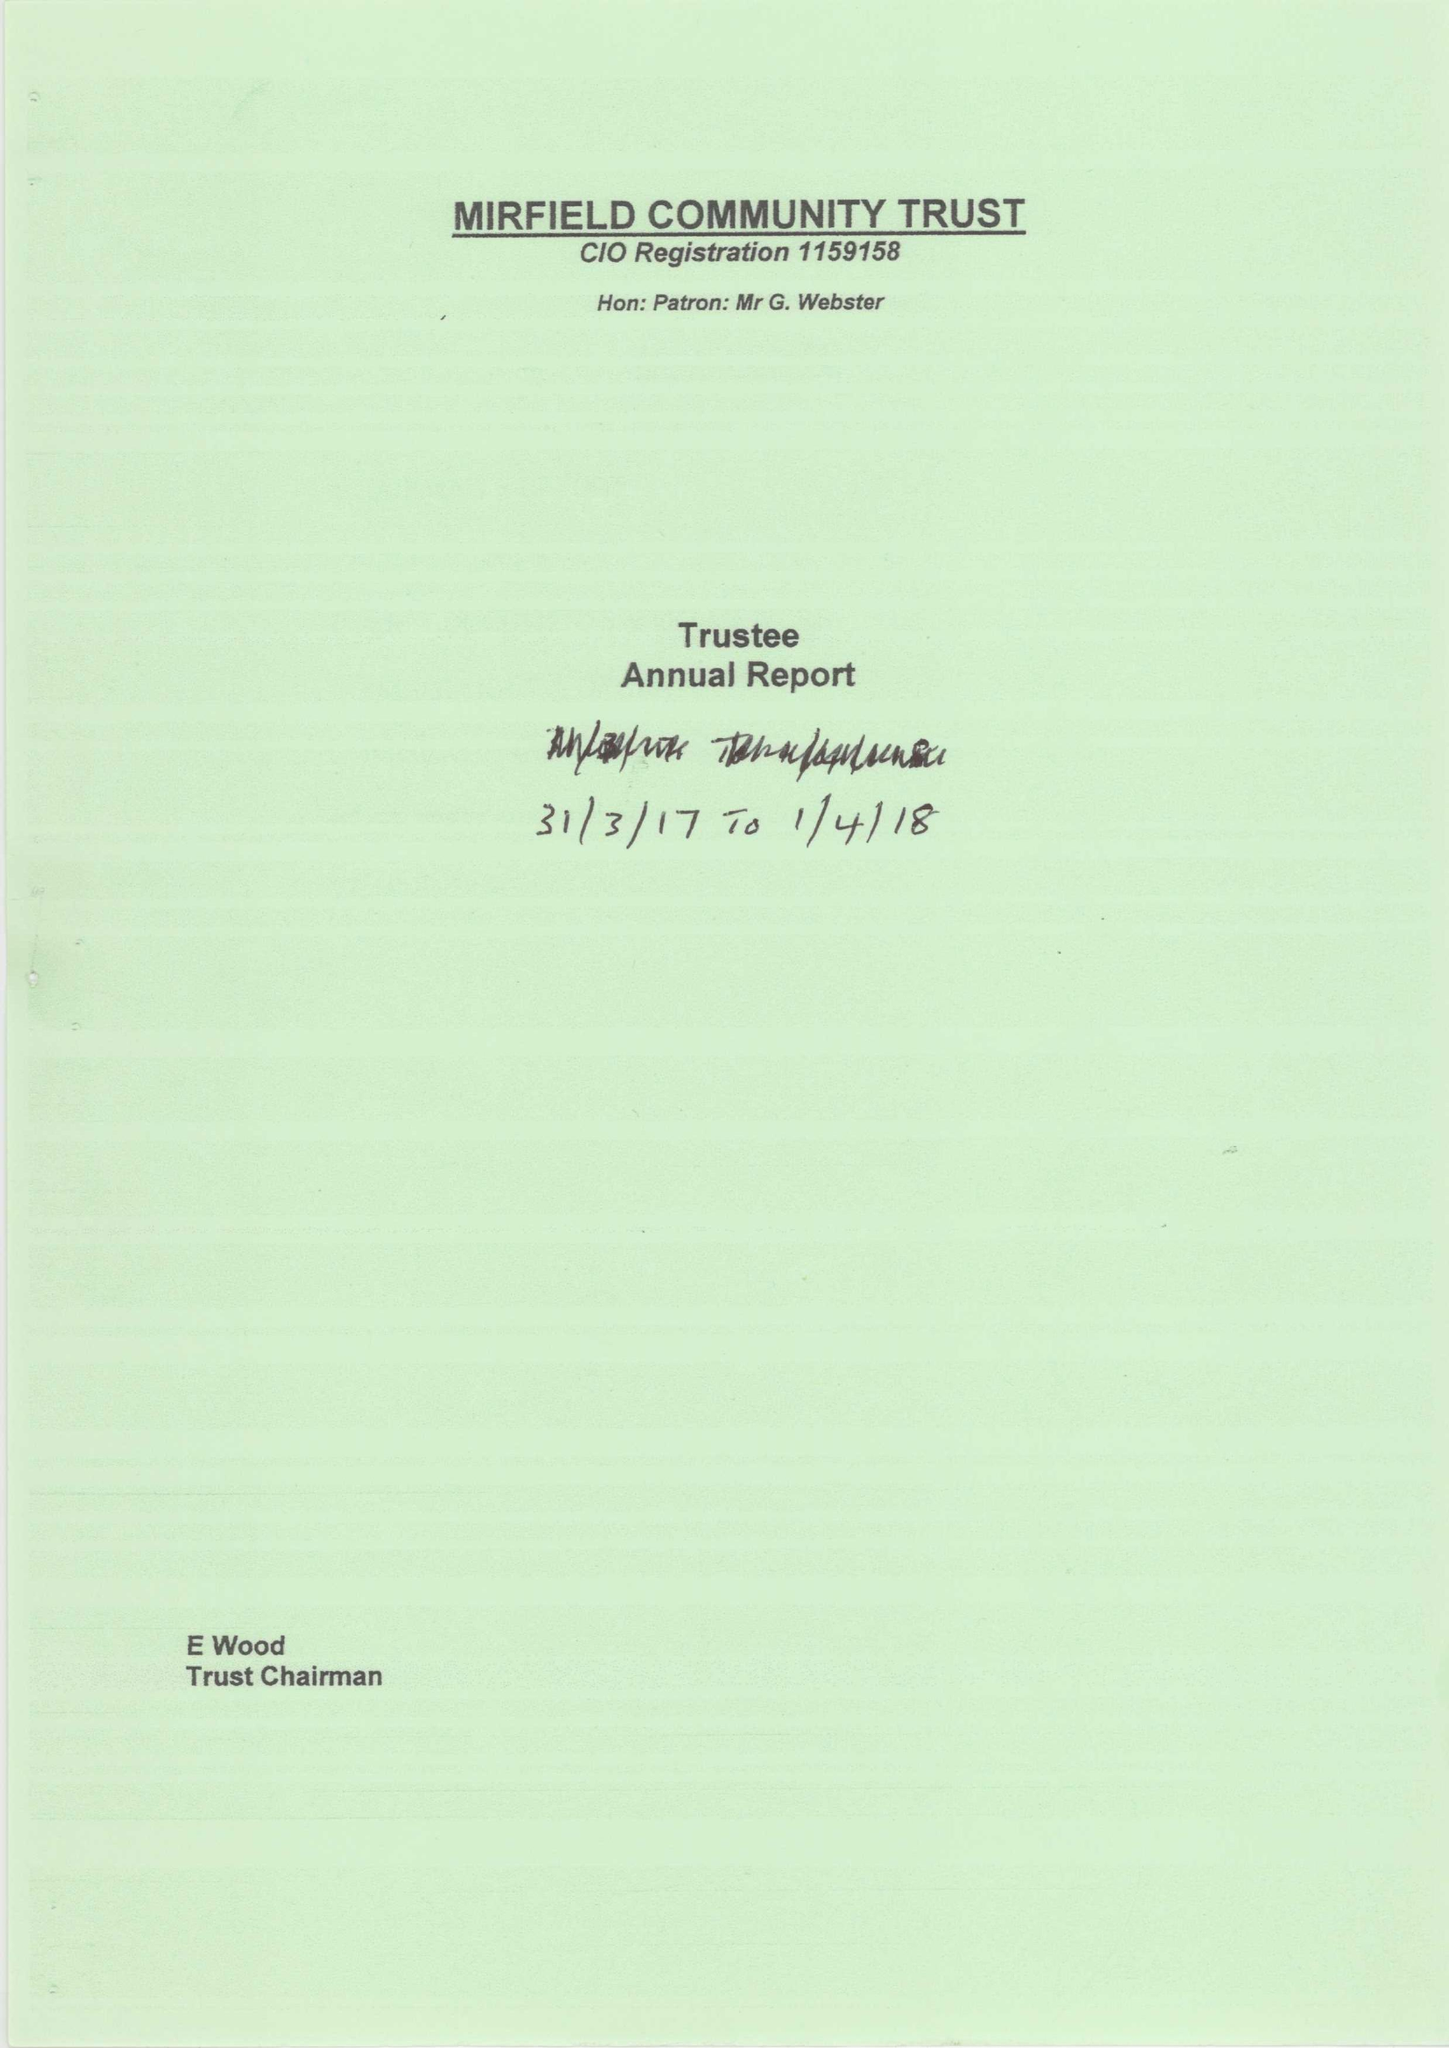What is the value for the spending_annually_in_british_pounds?
Answer the question using a single word or phrase. 23936.00 